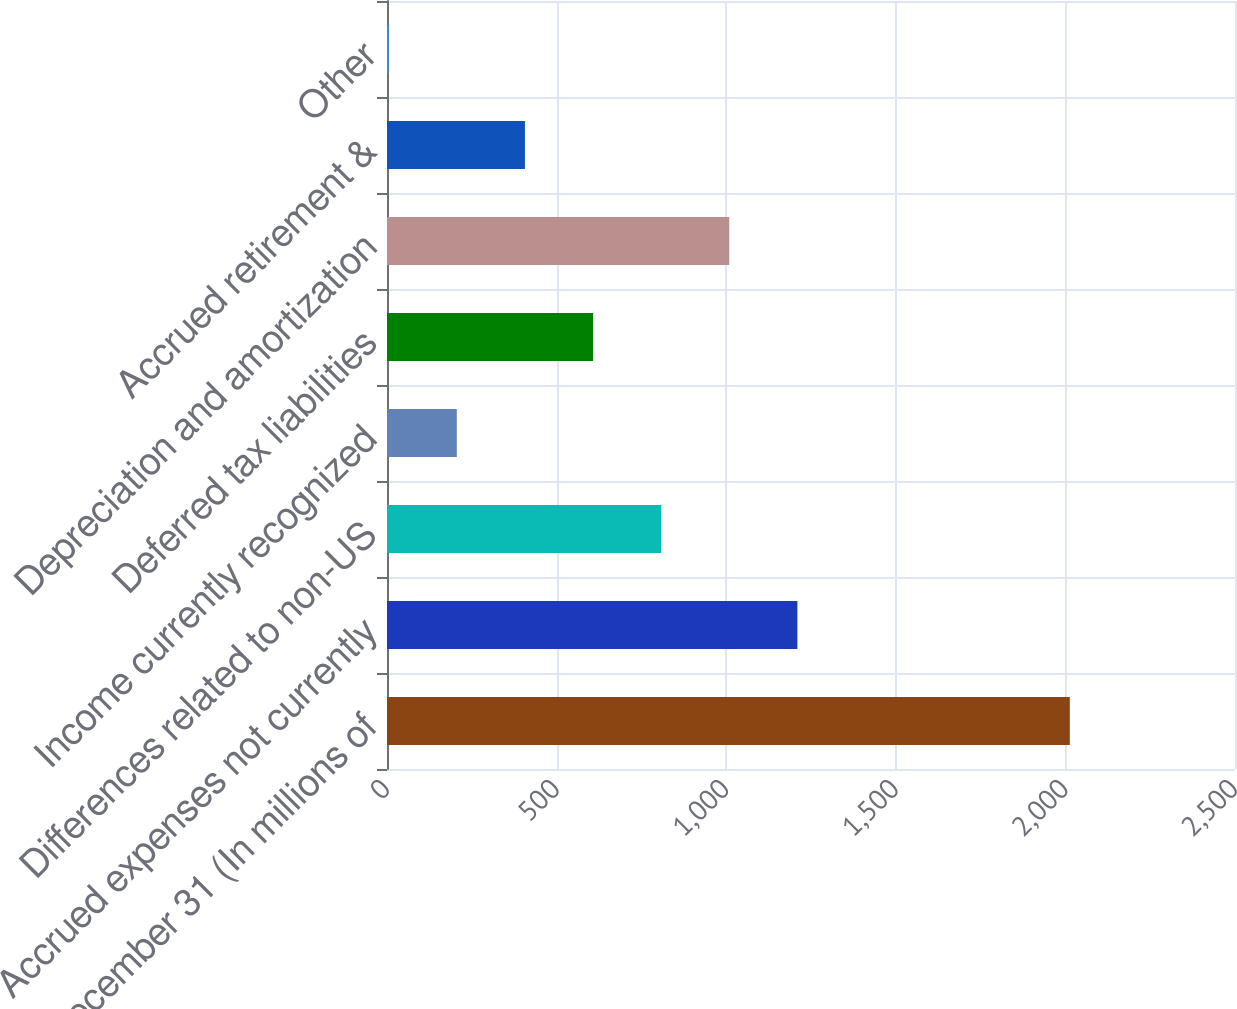Convert chart to OTSL. <chart><loc_0><loc_0><loc_500><loc_500><bar_chart><fcel>December 31 (In millions of<fcel>Accrued expenses not currently<fcel>Differences related to non-US<fcel>Income currently recognized<fcel>Deferred tax liabilities<fcel>Depreciation and amortization<fcel>Accrued retirement &<fcel>Other<nl><fcel>2013<fcel>1209.8<fcel>808.2<fcel>205.8<fcel>607.4<fcel>1009<fcel>406.6<fcel>5<nl></chart> 